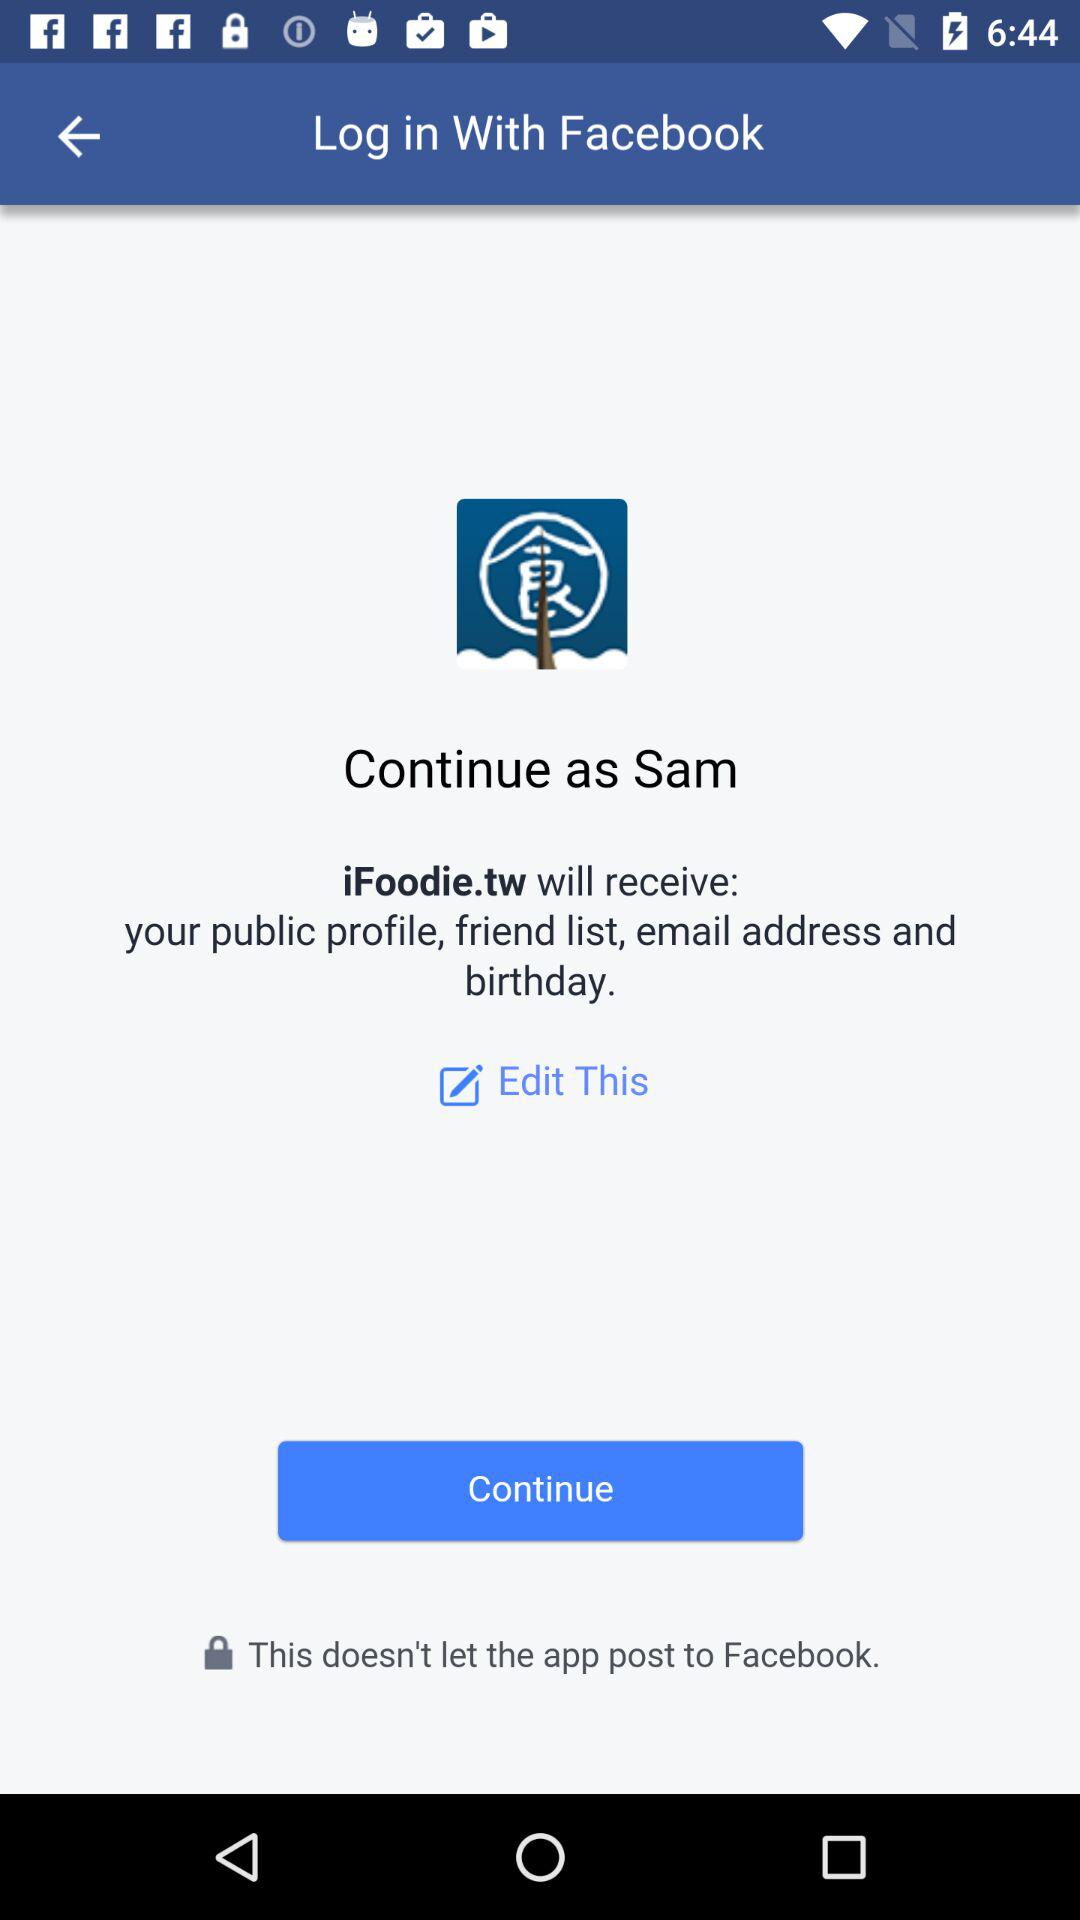By what user name can the application be continued? The user name with which the application can be continued is Sam. 